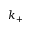Convert formula to latex. <formula><loc_0><loc_0><loc_500><loc_500>k _ { + }</formula> 